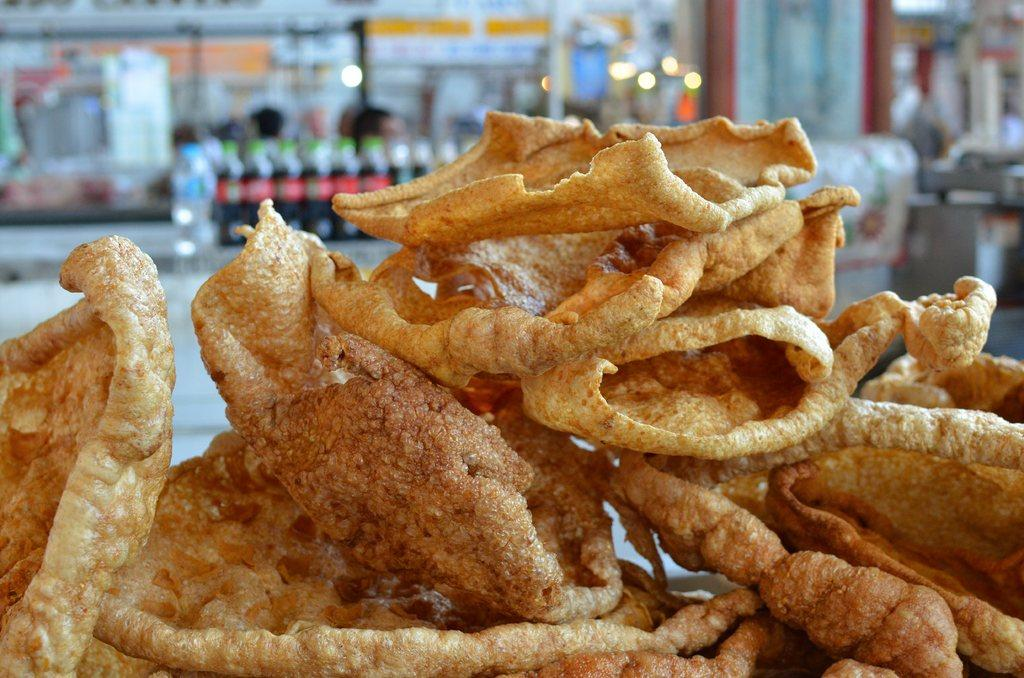What type of food can be seen in the image? The image contains fries in brown color. What else is visible in the background of the image? There are cool drink bottles in the background. Can you describe the setting where the image was taken? The image appears to be taken in a restaurant setting. How is the background of the image depicted? The background is blurred. Can you see any animals from the zoo in the image? There are no animals from the zoo present in the image. How many fingers are visible in the image? There are no fingers visible in the image. 